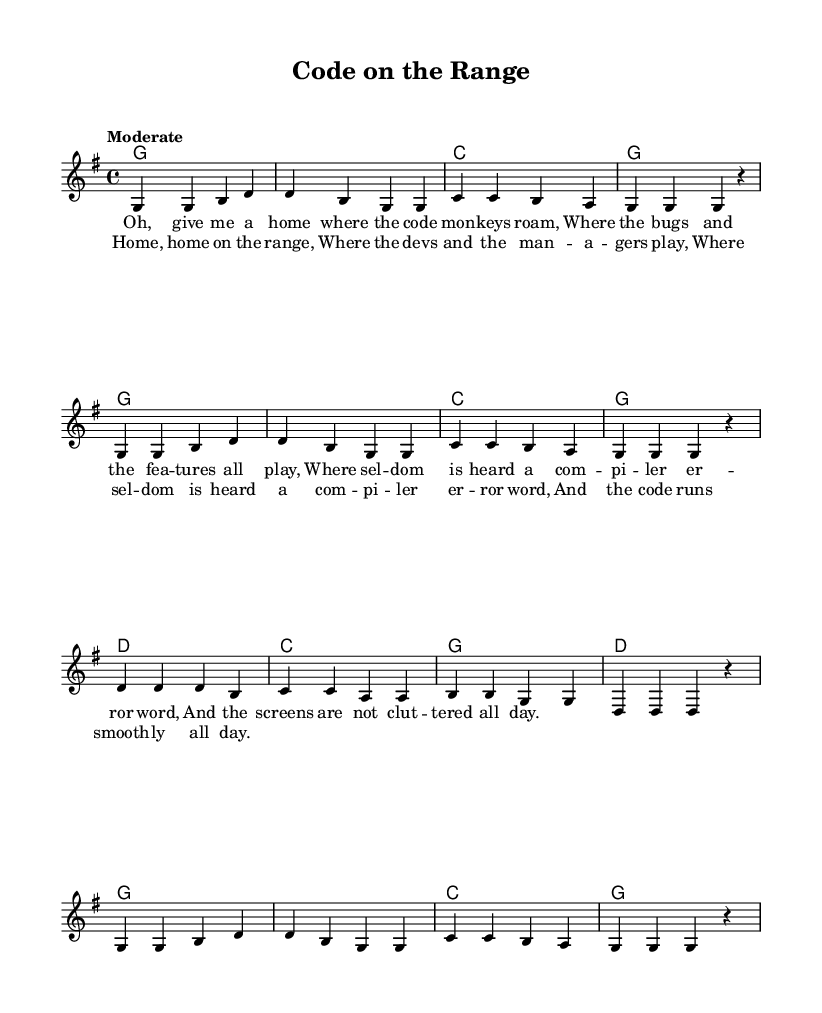What is the key signature of this music? The key signature is indicated at the beginning of the score and shows a single sharp, which means the key is G major.
Answer: G major What is the time signature of this music? The time signature is displayed at the start of the piece, showing a 4 over 4 configuration, which indicates four beats per measure.
Answer: 4/4 What is the tempo marking for this piece? The tempo marking is written above the staff and specifies "Moderate," indicating a moderate pace for performing the piece.
Answer: Moderate How many measures are in the melody section? Counting the measures within the melody, we find a total of 16 measures present in the section.
Answer: 16 What is the first lyric line of the verse? The first lyric line is presented with music notes aligned underneath it, stating "Oh, give me a home where the code mon -- keys roam."
Answer: Oh, give me a home where the code mon -- keys roam What is the structure of the piece? Analyzing the layout, we observe that the piece consists of verses and a chorus, typical for country songs, which are followed by repeated sections.
Answer: Verse and chorus What is the theme of the lyrics in this piece? The lyrics focus on themes of software engineering and coding life, expressing a longing for a harmonious work environment in programming.
Answer: Coding life 